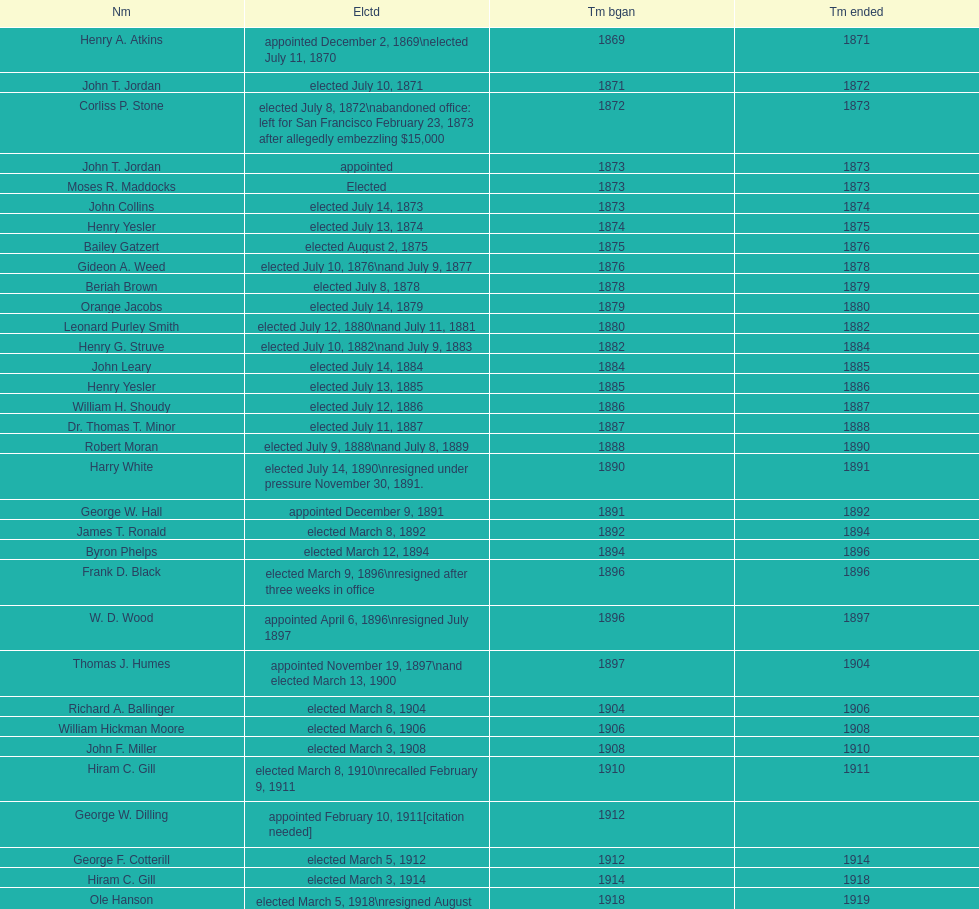Who started their period in 1890? Harry White. 